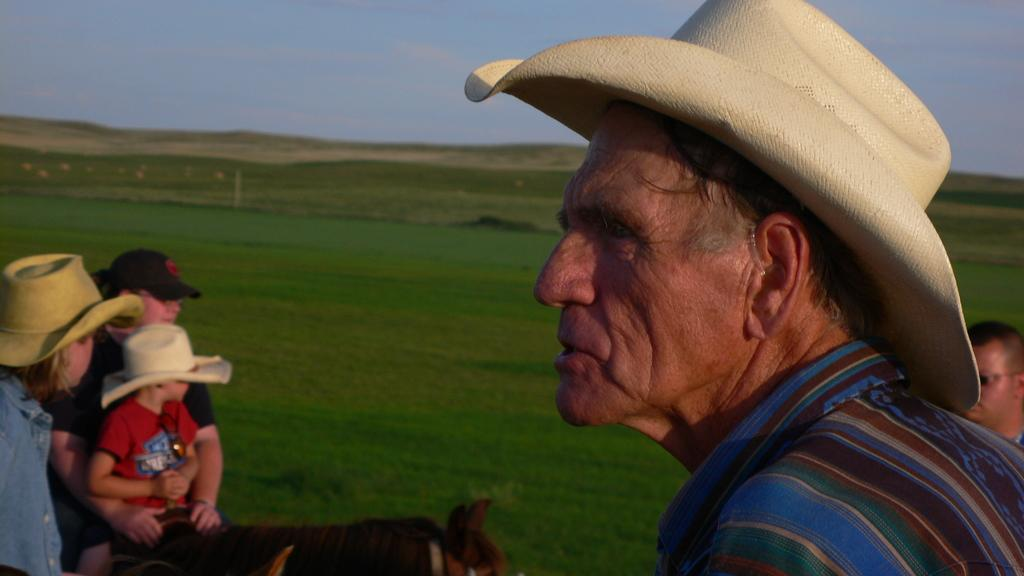What is the man in the image wearing on his head? The man in the image is wearing a hat. What direction is the man looking in the image? The man is looking aside in the image. What activity is the girl and child engaged in the image? The girl and child are riding a horse in the image. Who is present behind the girl and child? There is a man behind the girl and child in the image. What type of vegetation can be seen in the background of the image? There are grass patches in the background of the image. What type of bread is being used to paint the horse in the image? There is no bread or painting activity present in the image. What is the man's interest in the girl and child riding the horse in the image? The image does not provide information about the man's interest or emotions towards the girl and child riding the horse. 